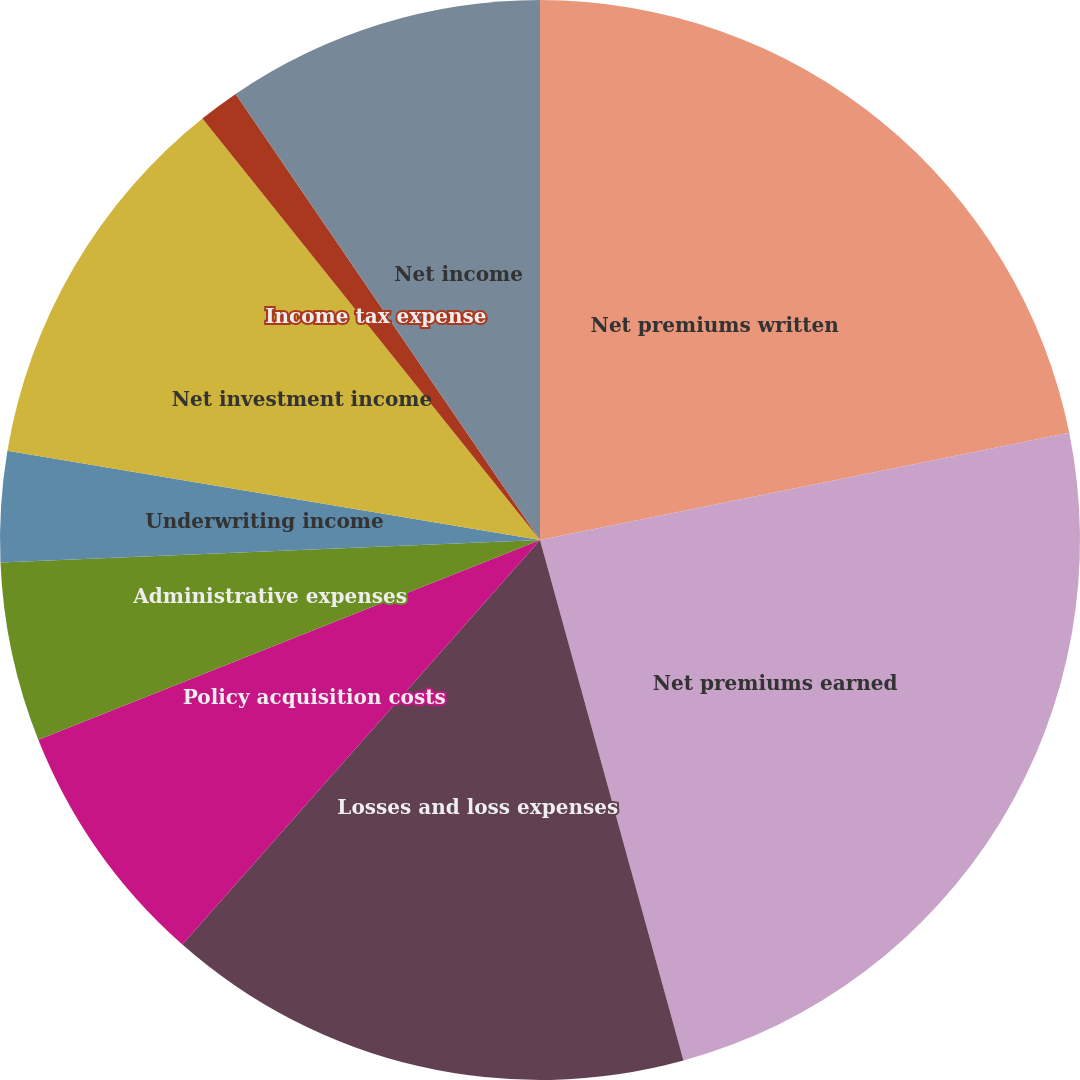<chart> <loc_0><loc_0><loc_500><loc_500><pie_chart><fcel>Net premiums written<fcel>Net premiums earned<fcel>Losses and loss expenses<fcel>Policy acquisition costs<fcel>Administrative expenses<fcel>Underwriting income<fcel>Net investment income<fcel>Income tax expense<fcel>Net income<nl><fcel>21.82%<fcel>23.9%<fcel>15.8%<fcel>7.45%<fcel>5.37%<fcel>3.3%<fcel>11.61%<fcel>1.22%<fcel>9.53%<nl></chart> 